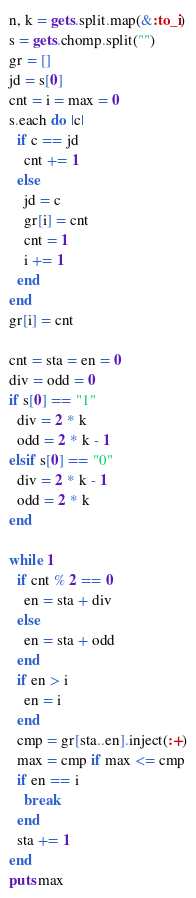<code> <loc_0><loc_0><loc_500><loc_500><_Ruby_>n, k = gets.split.map(&:to_i)
s = gets.chomp.split("")
gr = []
jd = s[0]
cnt = i = max = 0
s.each do |c|
  if c == jd
    cnt += 1
  else
    jd = c
    gr[i] = cnt
    cnt = 1
    i += 1
  end
end
gr[i] = cnt

cnt = sta = en = 0
div = odd = 0
if s[0] == "1"
  div = 2 * k
  odd = 2 * k - 1
elsif s[0] == "0"
  div = 2 * k - 1
  odd = 2 * k
end

while 1
  if cnt % 2 == 0
    en = sta + div
  else
    en = sta + odd
  end
  if en > i
    en = i
  end
  cmp = gr[sta..en].inject(:+)
  max = cmp if max <= cmp
  if en == i
    break
  end
  sta += 1
end
puts max</code> 